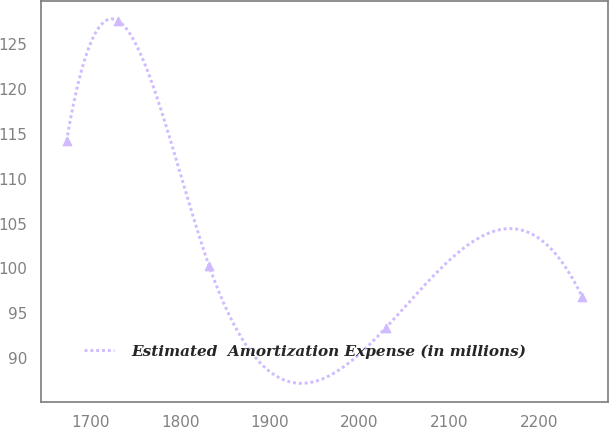Convert chart to OTSL. <chart><loc_0><loc_0><loc_500><loc_500><line_chart><ecel><fcel>Estimated  Amortization Expense (in millions)<nl><fcel>1673.46<fcel>114.21<nl><fcel>1730.94<fcel>127.63<nl><fcel>1832.52<fcel>100.23<nl><fcel>2029.45<fcel>93.39<nl><fcel>2248.23<fcel>96.81<nl></chart> 